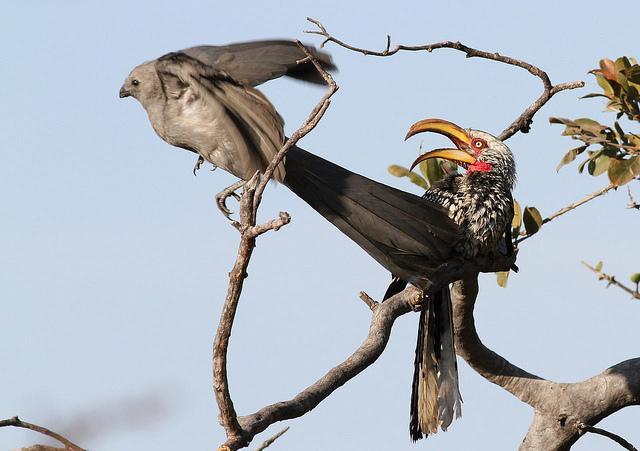What color is the bird's beak in the back?
Be succinct. Yellow. How many birds?
Concise answer only. 2. Is that a parrot?
Write a very short answer. No. 